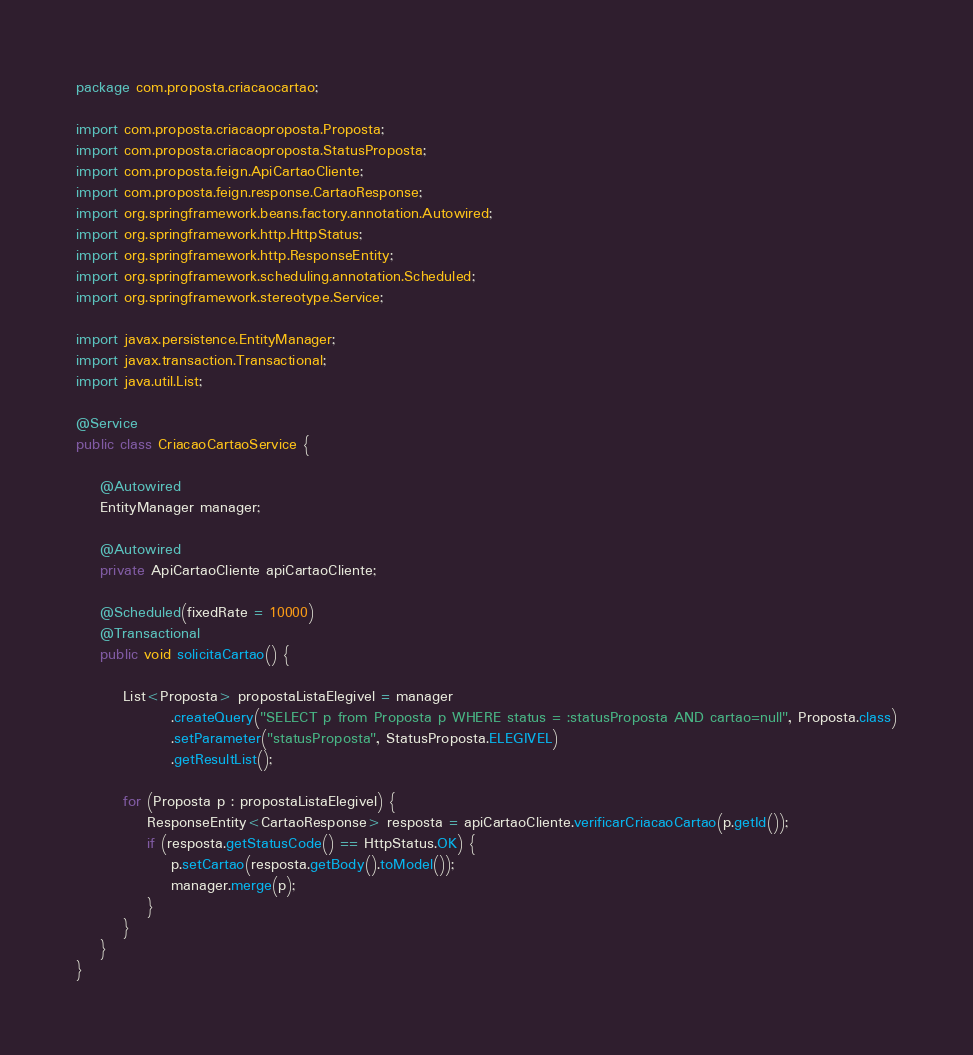Convert code to text. <code><loc_0><loc_0><loc_500><loc_500><_Java_>package com.proposta.criacaocartao;

import com.proposta.criacaoproposta.Proposta;
import com.proposta.criacaoproposta.StatusProposta;
import com.proposta.feign.ApiCartaoCliente;
import com.proposta.feign.response.CartaoResponse;
import org.springframework.beans.factory.annotation.Autowired;
import org.springframework.http.HttpStatus;
import org.springframework.http.ResponseEntity;
import org.springframework.scheduling.annotation.Scheduled;
import org.springframework.stereotype.Service;

import javax.persistence.EntityManager;
import javax.transaction.Transactional;
import java.util.List;

@Service
public class CriacaoCartaoService {

    @Autowired
    EntityManager manager;

    @Autowired
    private ApiCartaoCliente apiCartaoCliente;

    @Scheduled(fixedRate = 10000)
    @Transactional
    public void solicitaCartao() {

        List<Proposta> propostaListaElegivel = manager
                .createQuery("SELECT p from Proposta p WHERE status = :statusProposta AND cartao=null", Proposta.class)
                .setParameter("statusProposta", StatusProposta.ELEGIVEL)
                .getResultList();

        for (Proposta p : propostaListaElegivel) {
            ResponseEntity<CartaoResponse> resposta = apiCartaoCliente.verificarCriacaoCartao(p.getId());
            if (resposta.getStatusCode() == HttpStatus.OK) {
                p.setCartao(resposta.getBody().toModel());
                manager.merge(p);
            }
        }
    }
}
</code> 